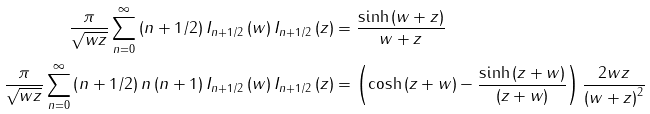<formula> <loc_0><loc_0><loc_500><loc_500>\frac { \pi } { \sqrt { w z } } \sum _ { n = 0 } ^ { \infty } \left ( n + 1 / 2 \right ) I _ { n + 1 / 2 } \left ( w \right ) I _ { n + 1 / 2 } \left ( z \right ) & = \frac { \sinh \left ( w + z \right ) } { w + z } \\ \frac { \pi } { \sqrt { w z } } \sum _ { n = 0 } ^ { \infty } \left ( n + 1 / 2 \right ) n \left ( n + 1 \right ) I _ { n + 1 / 2 } \left ( w \right ) I _ { n + 1 / 2 } \left ( z \right ) & = \left ( \cosh \left ( z + w \right ) - \frac { \sinh \left ( z + w \right ) } { \left ( z + w \right ) } \right ) \frac { 2 w z } { \left ( w + z \right ) ^ { 2 } }</formula> 